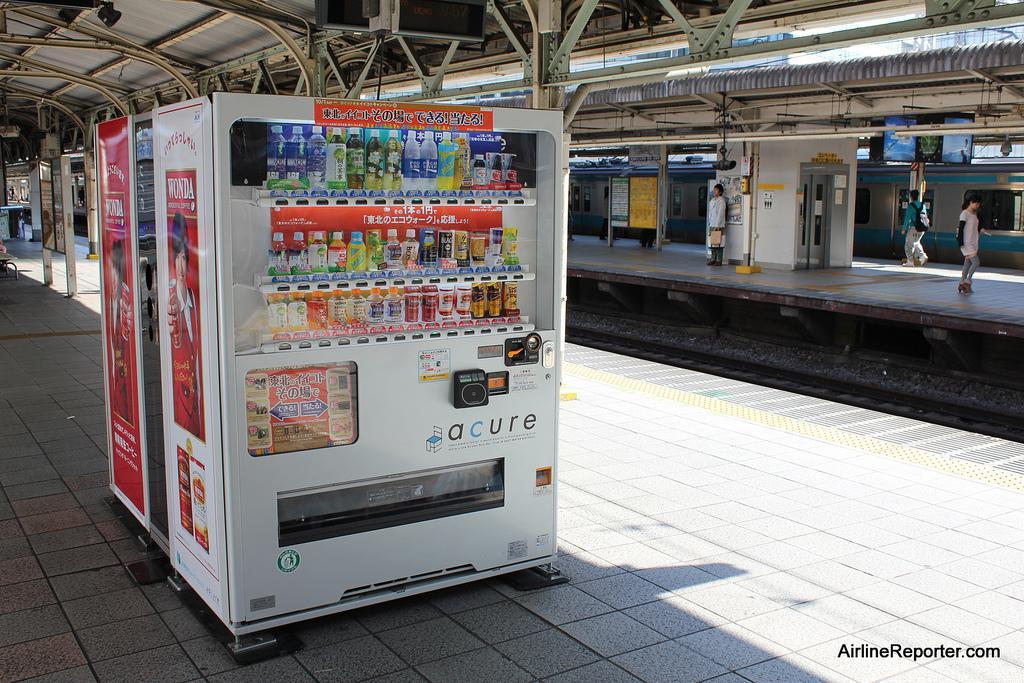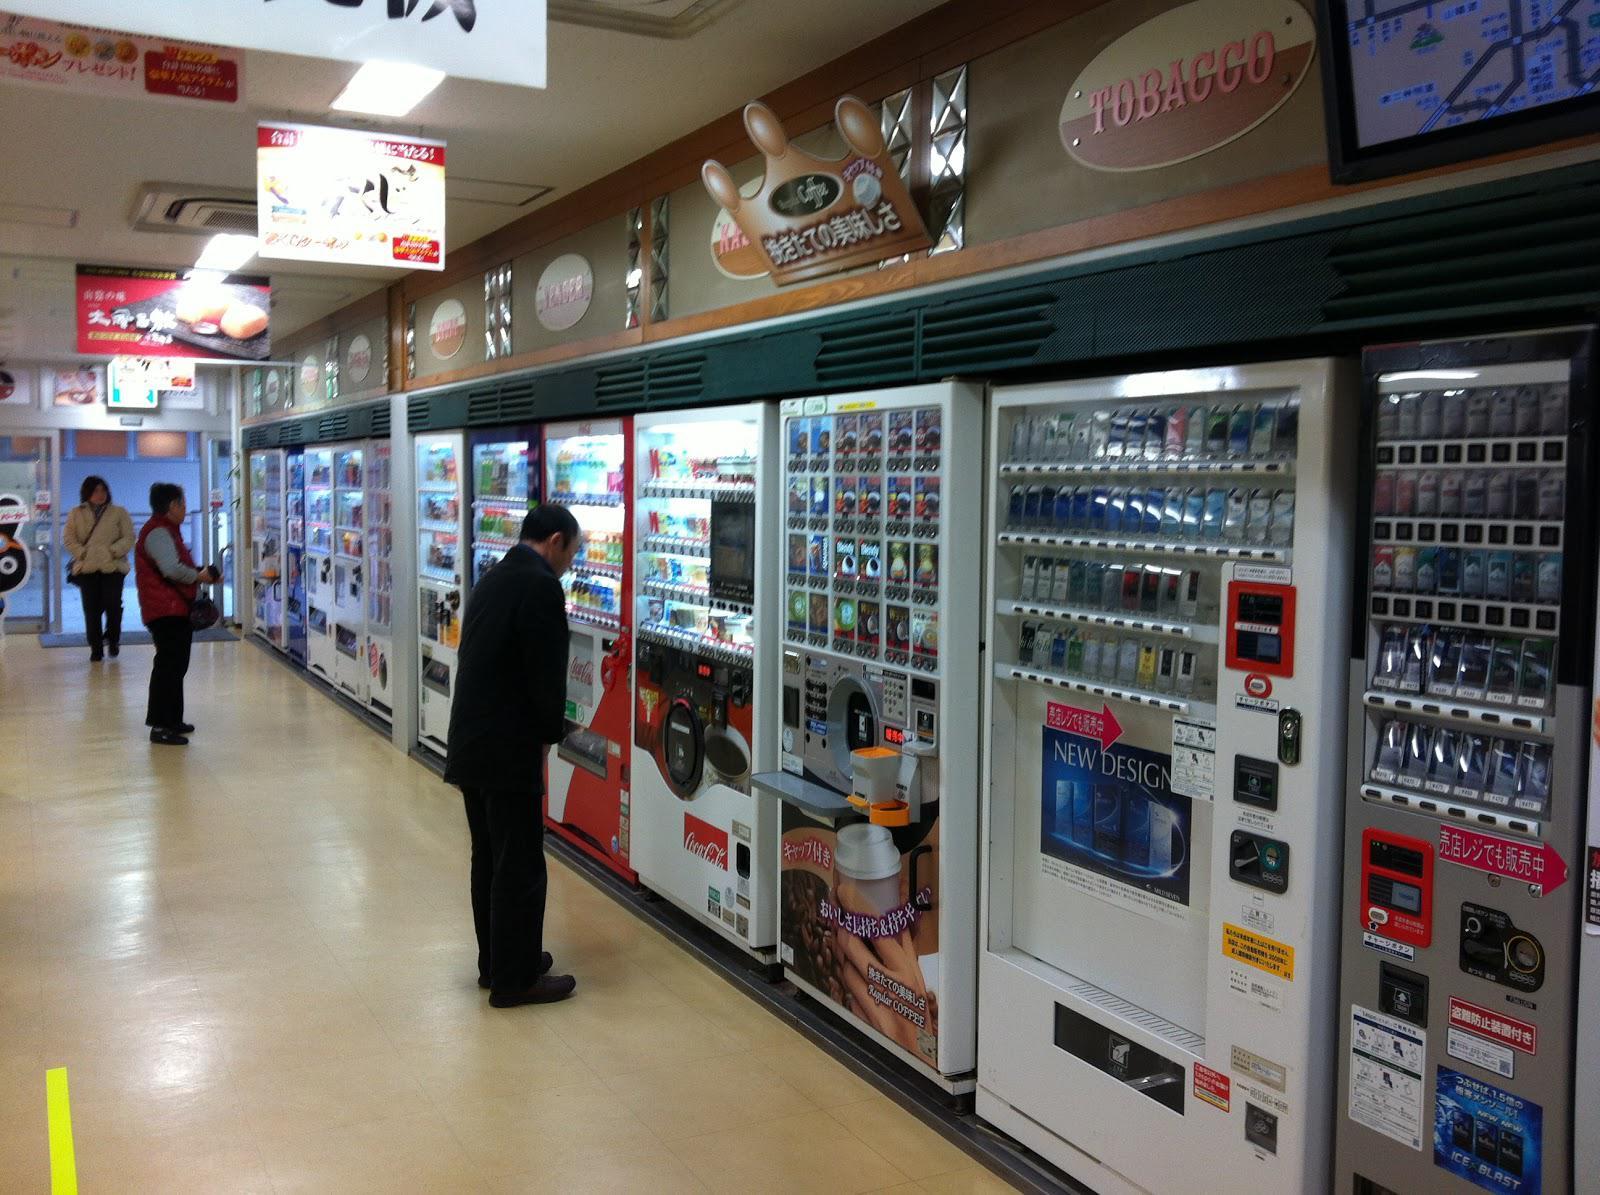The first image is the image on the left, the second image is the image on the right. Given the left and right images, does the statement "At least one person is near the machines in the image on the right." hold true? Answer yes or no. Yes. The first image is the image on the left, the second image is the image on the right. For the images shown, is this caption "In the right image, there is no less than one person standing in front of and staring ahead at a row of vending machines" true? Answer yes or no. Yes. 